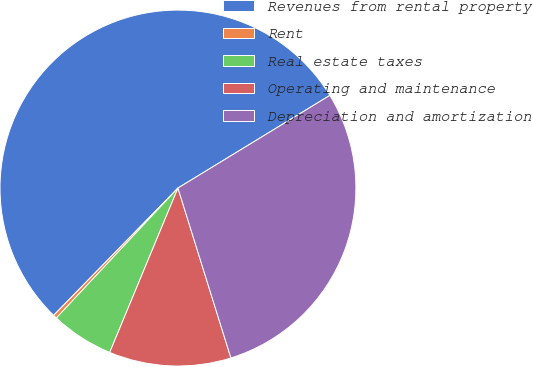<chart> <loc_0><loc_0><loc_500><loc_500><pie_chart><fcel>Revenues from rental property<fcel>Rent<fcel>Real estate taxes<fcel>Operating and maintenance<fcel>Depreciation and amortization<nl><fcel>53.97%<fcel>0.34%<fcel>5.71%<fcel>11.07%<fcel>28.91%<nl></chart> 